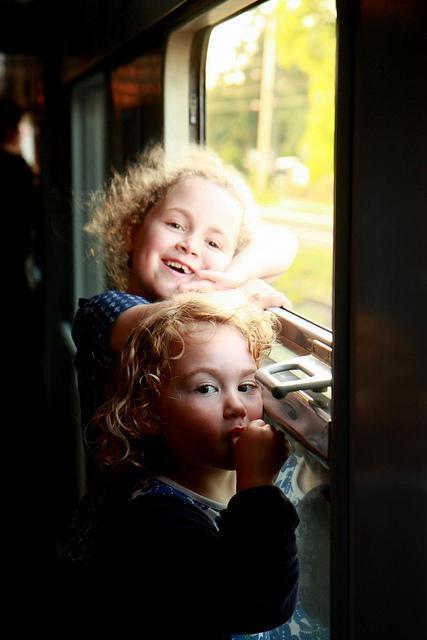How many windows are on the train?
Give a very brief answer. 1. How many people are there?
Give a very brief answer. 2. How many dogs paws are white?
Give a very brief answer. 0. 